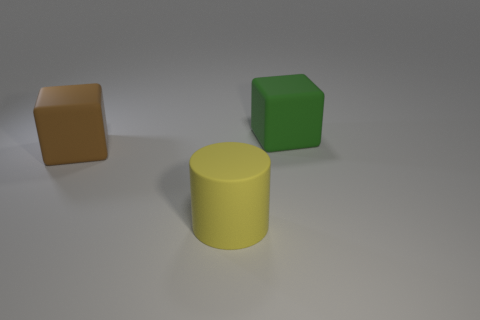Are there any cylinders in front of the big yellow rubber thing?
Offer a very short reply. No. Is the material of the yellow cylinder the same as the cube that is behind the brown rubber cube?
Your answer should be compact. Yes. Do the big rubber thing that is behind the big brown rubber block and the big yellow object have the same shape?
Offer a very short reply. No. How many big cylinders have the same material as the green block?
Your answer should be compact. 1. What number of things are either rubber cubes that are to the left of the large green matte block or big matte cubes?
Offer a terse response. 2. The cylinder has what size?
Make the answer very short. Large. The cube that is behind the big block in front of the green rubber thing is made of what material?
Offer a very short reply. Rubber. Does the rubber block to the right of the matte cylinder have the same size as the yellow matte thing?
Offer a terse response. Yes. Is there another large rubber cylinder of the same color as the large rubber cylinder?
Your response must be concise. No. What number of things are either objects that are on the left side of the big yellow object or rubber cubes to the left of the yellow matte object?
Offer a terse response. 1. 